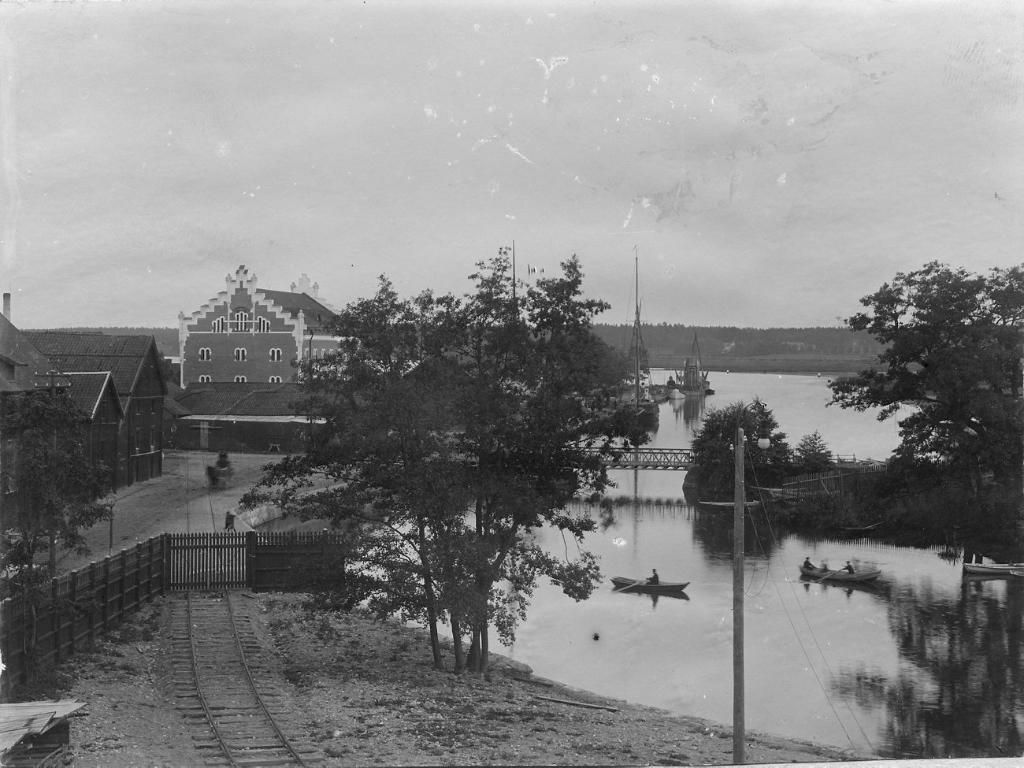How would you summarize this image in a sentence or two? In this black and white image there are buildings, trees, railway track, railing and few boats on the river, there is a bridge and in the background there is the sky. 